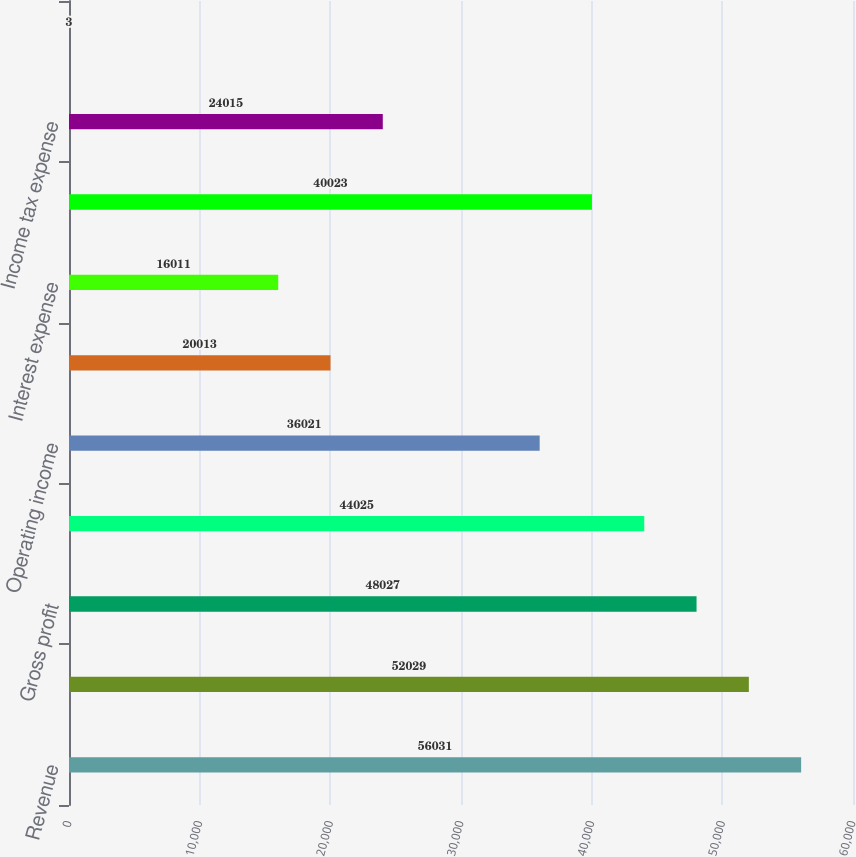Convert chart to OTSL. <chart><loc_0><loc_0><loc_500><loc_500><bar_chart><fcel>Revenue<fcel>Cost of goods sold<fcel>Gross profit<fcel>Selling general and<fcel>Operating income<fcel>Investment income and other<fcel>Interest expense<fcel>Earnings before income tax<fcel>Income tax expense<fcel>Equity in income (loss) of<nl><fcel>56031<fcel>52029<fcel>48027<fcel>44025<fcel>36021<fcel>20013<fcel>16011<fcel>40023<fcel>24015<fcel>3<nl></chart> 